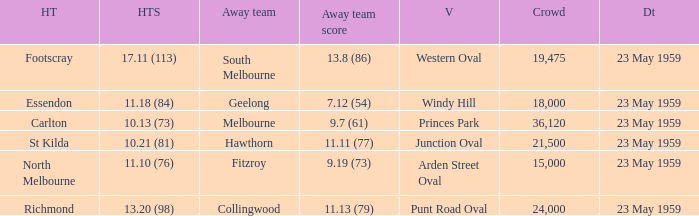What was the home team's score at the game that had a crowd larger than 24,000? 10.13 (73). 